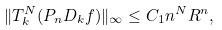<formula> <loc_0><loc_0><loc_500><loc_500>\| T _ { k } ^ { N } ( P _ { n } D _ { k } f ) \| _ { \infty } \leq C _ { 1 } n ^ { N } R ^ { n } ,</formula> 